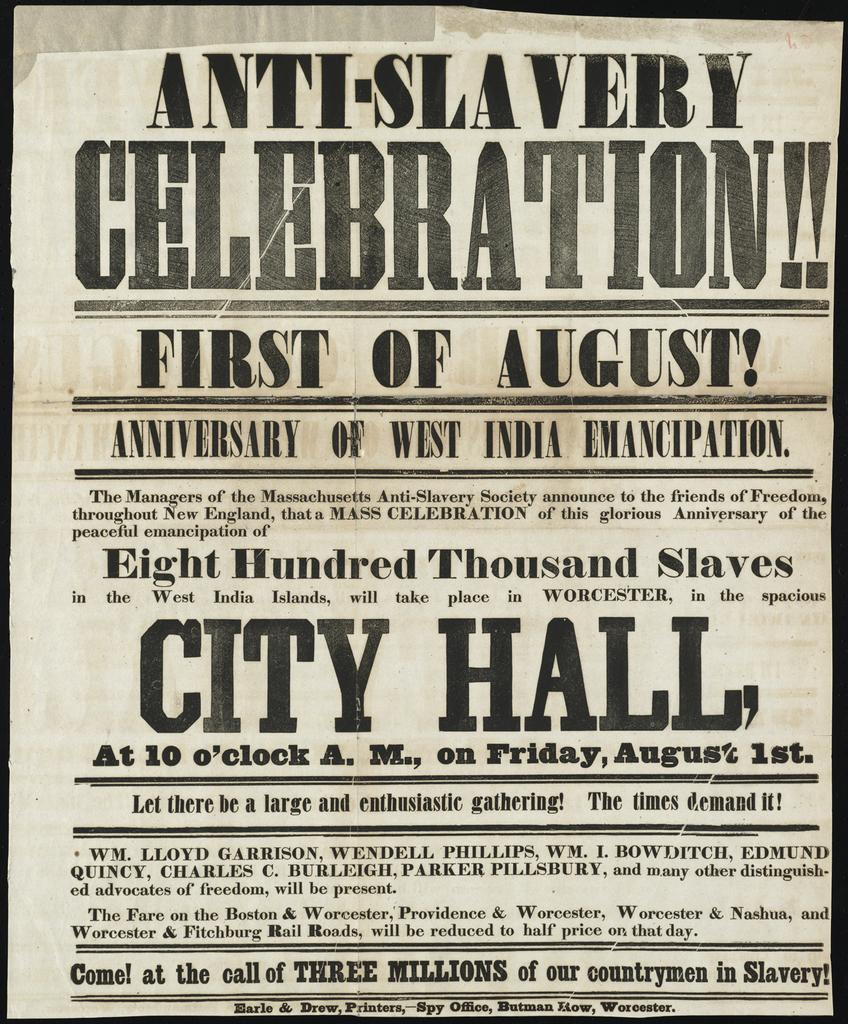<image>
Create a compact narrative representing the image presented. a paper that has an anti-slavery celebration on it 